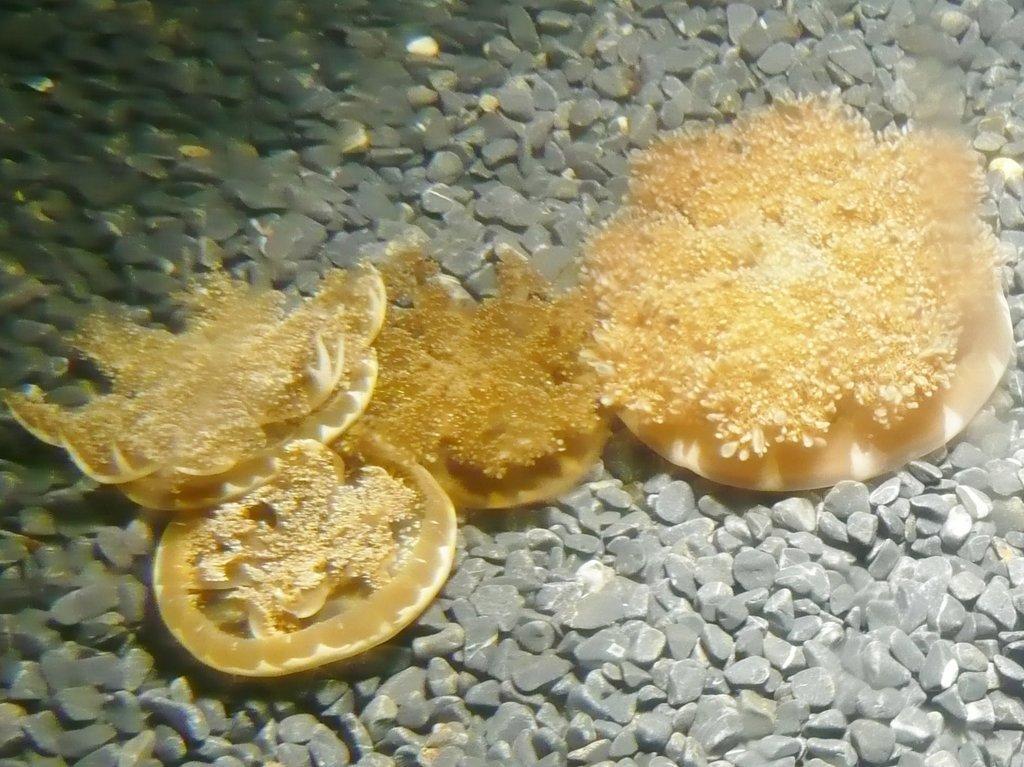Describe this image in one or two sentences. In the center of the image we can see water plants and stones. 